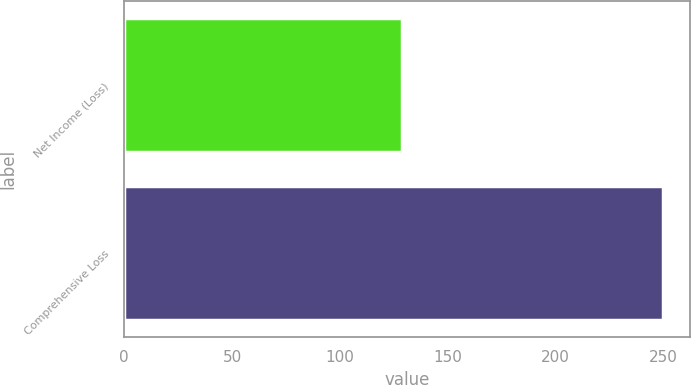Convert chart. <chart><loc_0><loc_0><loc_500><loc_500><bar_chart><fcel>Net Income (Loss)<fcel>Comprehensive Loss<nl><fcel>129<fcel>250<nl></chart> 